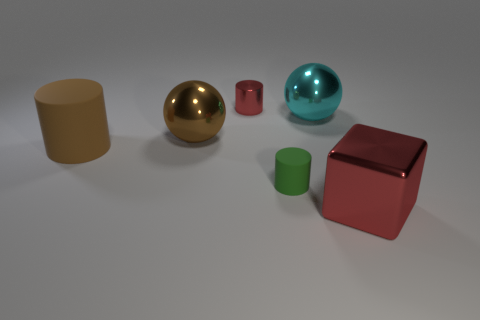What size is the brown object that is to the right of the big rubber cylinder?
Provide a short and direct response. Large. There is a red shiny object on the left side of the block; is its size the same as the green rubber cylinder on the right side of the tiny red object?
Give a very brief answer. Yes. How many big cylinders are the same material as the big cube?
Provide a short and direct response. 0. What color is the small rubber cylinder?
Offer a very short reply. Green. Are there any brown spheres to the left of the big red shiny cube?
Give a very brief answer. Yes. Is the color of the big metal block the same as the small metal cylinder?
Give a very brief answer. Yes. What number of metallic objects are the same color as the big cylinder?
Make the answer very short. 1. How big is the red object left of the red metal thing in front of the large brown cylinder?
Keep it short and to the point. Small. What is the shape of the large cyan object?
Your response must be concise. Sphere. There is a small cylinder that is in front of the tiny metal cylinder; what material is it?
Give a very brief answer. Rubber. 